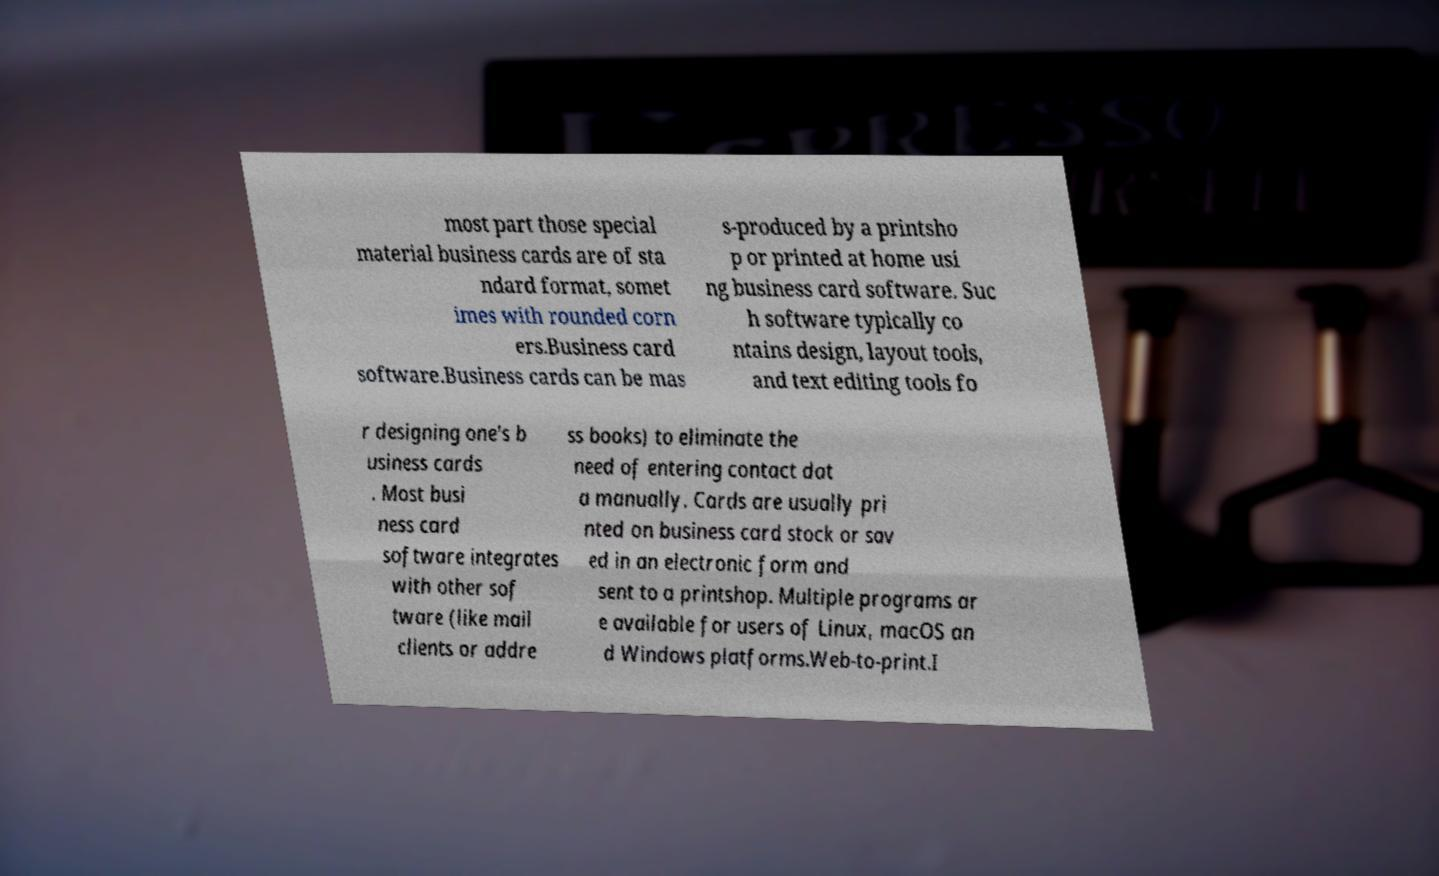For documentation purposes, I need the text within this image transcribed. Could you provide that? most part those special material business cards are of sta ndard format, somet imes with rounded corn ers.Business card software.Business cards can be mas s-produced by a printsho p or printed at home usi ng business card software. Suc h software typically co ntains design, layout tools, and text editing tools fo r designing one's b usiness cards . Most busi ness card software integrates with other sof tware (like mail clients or addre ss books) to eliminate the need of entering contact dat a manually. Cards are usually pri nted on business card stock or sav ed in an electronic form and sent to a printshop. Multiple programs ar e available for users of Linux, macOS an d Windows platforms.Web-to-print.I 